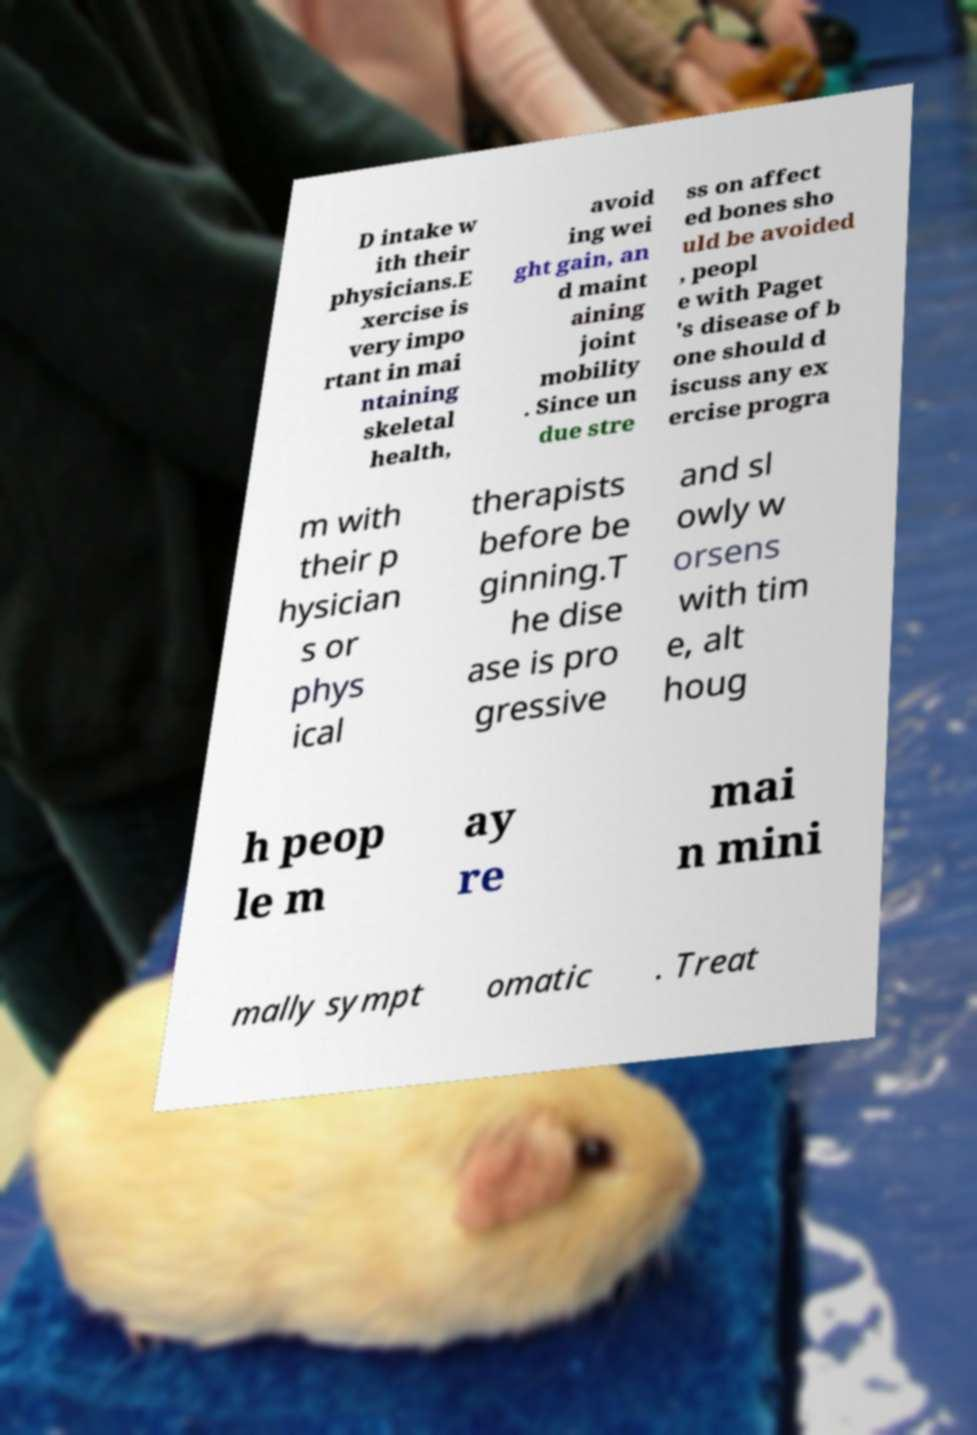For documentation purposes, I need the text within this image transcribed. Could you provide that? D intake w ith their physicians.E xercise is very impo rtant in mai ntaining skeletal health, avoid ing wei ght gain, an d maint aining joint mobility . Since un due stre ss on affect ed bones sho uld be avoided , peopl e with Paget 's disease of b one should d iscuss any ex ercise progra m with their p hysician s or phys ical therapists before be ginning.T he dise ase is pro gressive and sl owly w orsens with tim e, alt houg h peop le m ay re mai n mini mally sympt omatic . Treat 